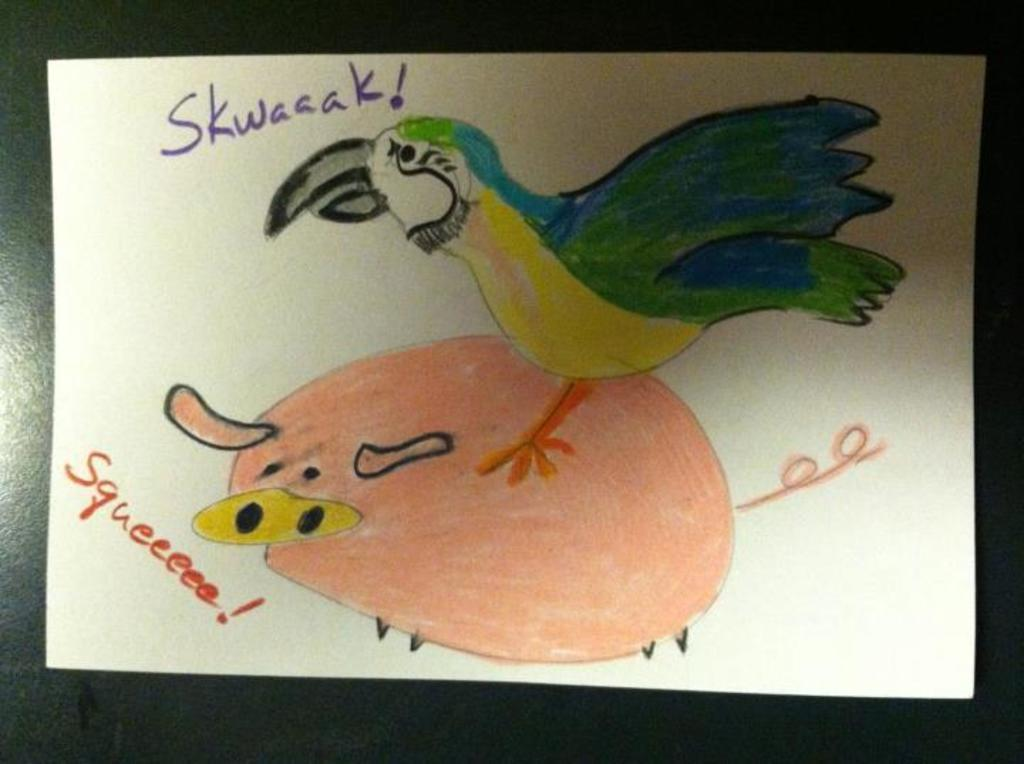What is depicted on the paper in the image? There is a drawing on a paper, and it features a bird standing on a pig. Where is the paper with the drawing located? The paper with the drawing is on a table. What type of organization is responsible for the lunchroom in the image? There is no mention of a lunchroom or any organization in the image. 